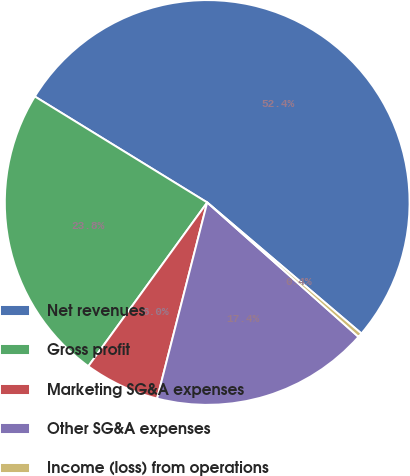<chart> <loc_0><loc_0><loc_500><loc_500><pie_chart><fcel>Net revenues<fcel>Gross profit<fcel>Marketing SG&A expenses<fcel>Other SG&A expenses<fcel>Income (loss) from operations<nl><fcel>52.43%<fcel>23.78%<fcel>6.01%<fcel>17.42%<fcel>0.35%<nl></chart> 